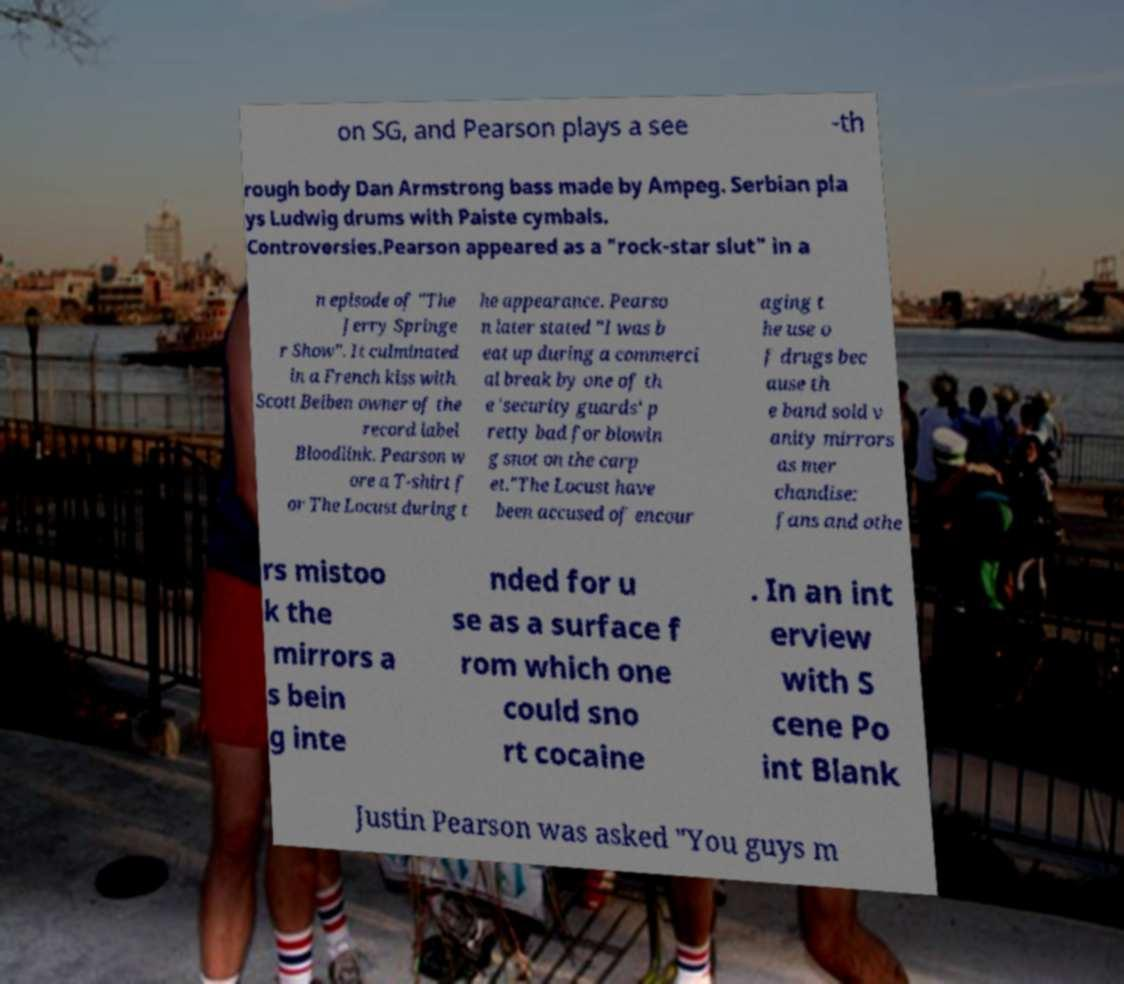Can you read and provide the text displayed in the image?This photo seems to have some interesting text. Can you extract and type it out for me? on SG, and Pearson plays a see -th rough body Dan Armstrong bass made by Ampeg. Serbian pla ys Ludwig drums with Paiste cymbals. Controversies.Pearson appeared as a "rock-star slut" in a n episode of "The Jerry Springe r Show". It culminated in a French kiss with Scott Beiben owner of the record label Bloodlink. Pearson w ore a T-shirt f or The Locust during t he appearance. Pearso n later stated "I was b eat up during a commerci al break by one of th e 'security guards' p retty bad for blowin g snot on the carp et."The Locust have been accused of encour aging t he use o f drugs bec ause th e band sold v anity mirrors as mer chandise: fans and othe rs mistoo k the mirrors a s bein g inte nded for u se as a surface f rom which one could sno rt cocaine . In an int erview with S cene Po int Blank Justin Pearson was asked "You guys m 